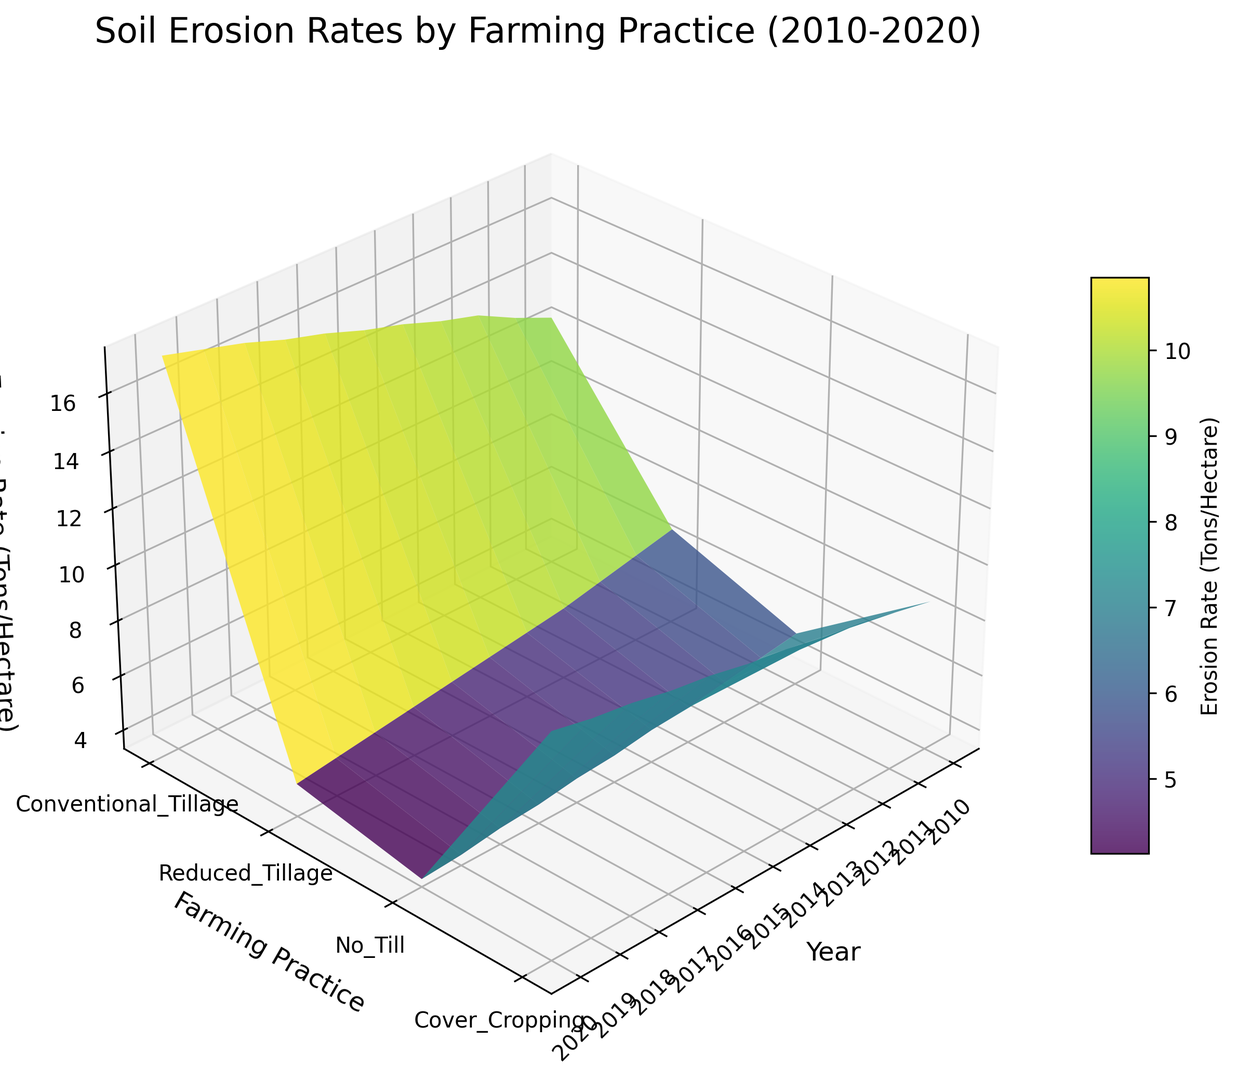What's the general trend in soil erosion rates for Conventional Tillage from 2010 to 2020? To determine the general trend, look at the height of the surface for Conventional Tillage from 2010 to 2020. The erosion rate mainly increases as the year progresses.
Answer: Increasing In which year does No-Till farming have the lowest erosion rate, and what is the rate? Examine the No-Till row, noting the lowest point in terms of height on the plot for each year. In 2020, the erosion rate is at its lowest.
Answer: 2020, 3.6 tons/hectare Which farming practice consistently shows the lowest erosion rates from 2010 to 2020? Compare the heights of the lowest points for each farming practice across all years. No-Till farming is consistently the lowest.
Answer: No-Till Calculate the average erosion rate for Cover Cropping over the years 2015 to 2020. Sum the erosion rates for Cover Cropping from 2015 to 2020 and divide by the number of years. (5.5 + 5.3 + 5.1 + 4.9 + 4.7 + 4.5) / 6 = 5.0 tons/hectare.
Answer: 5.0 tons/hectare Does Reduced Tillage have lower erosion rates than Conventional Tillage in 2018? Compare the height of the surface for Reduced Tillage and Conventional Tillage in 2018. Reduced Tillage has a lower erosion rate of 10.8 compared to 16.5 for Conventional Tillage.
Answer: Yes By how much did the erosion rate for Conventional Tillage increase from 2010 to 2020? Identify the erosion rates for Conventional Tillage in 2010 and 2020, and then calculate the difference. 17.3 - 12.5 = 4.8 tons/hectare.
Answer: 4.8 tons/hectare Which year shows the highest rate of erosion for Reduced Tillage, and what is this rate? Observe the highest point of the surface on the Reduced Tillage row across all years. The highest rate is in 2020.
Answer: 2020, 11.3 tons/hectare Compare the trend of erosion rates for No-Till and Reduced Tillage from 2010 to 2020. Which one shows a greater decrease? Assess the trend line for both practices. No-Till shows a noticeable decrease, whereas Reduced Tillage stays relatively stable but increases slightly overall. No-Till shows a greater decrease from 5.2 to 3.6.
Answer: No-Till Determine the difference in erosion rates between Cover Cropping and No-Till farming in 2014. Look at the heights of the surfaces for both practices in 2014 and find the difference. 5.7 - 4.5 = 1.2 tons/hectare.
Answer: 1.2 tons/hectare 